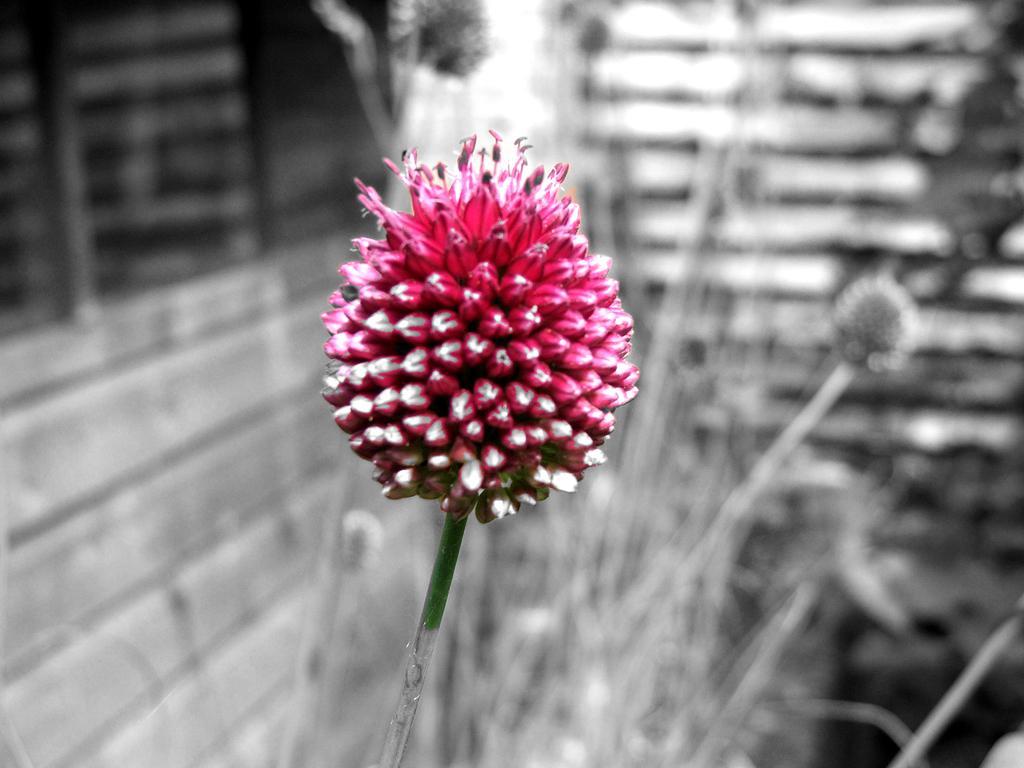Can you describe this image briefly? This image consists of a flower it is in pink color. In the background, we can see a wall and a plant. The background is blurred. 